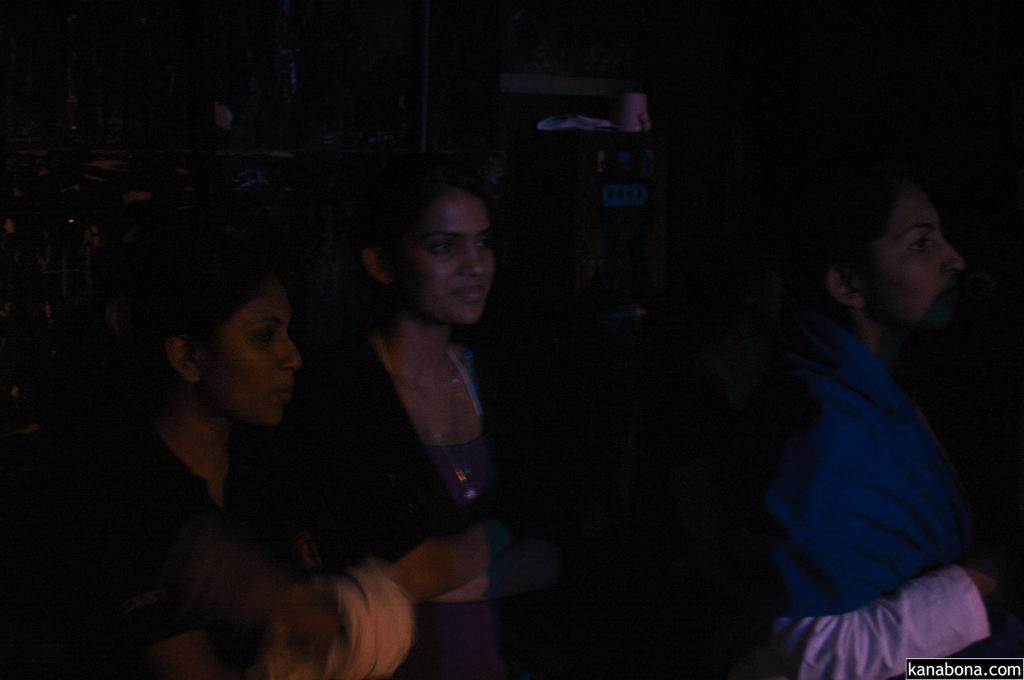Who or what can be seen in the image? A: There are people in the image. What can be observed about the background of the image? The background of the image is dark. What else is present in the image besides the people? There are objects in the image. What type of test is being conducted in the image? There is no indication of a test being conducted in the image. Can you tell me how many parents are present in the image? There is no mention of parents in the image. 